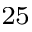Convert formula to latex. <formula><loc_0><loc_0><loc_500><loc_500>^ { 2 5 }</formula> 